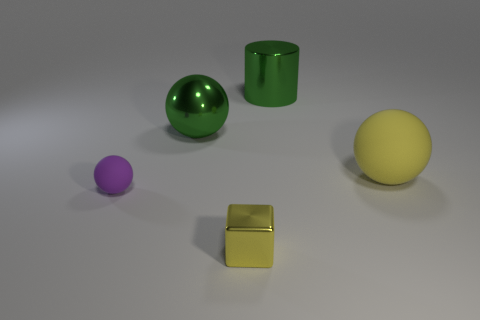What number of other yellow metallic things are the same size as the yellow metallic thing?
Ensure brevity in your answer.  0. There is a yellow thing that is in front of the purple sphere; what number of tiny spheres are in front of it?
Ensure brevity in your answer.  0. There is a sphere that is on the left side of the large cylinder and right of the tiny purple thing; what is its size?
Keep it short and to the point. Large. Are there more purple rubber things than large gray matte cubes?
Offer a very short reply. Yes. Are there any large objects of the same color as the cylinder?
Ensure brevity in your answer.  Yes. Is the size of the green thing to the left of the green metallic cylinder the same as the big matte thing?
Provide a short and direct response. Yes. Is the number of large rubber balls less than the number of tiny gray rubber things?
Offer a very short reply. No. Is there a yellow thing that has the same material as the tiny purple ball?
Your answer should be very brief. Yes. What shape is the matte thing that is right of the small purple sphere?
Make the answer very short. Sphere. Is the color of the rubber ball to the right of the green shiny cylinder the same as the tiny metal thing?
Ensure brevity in your answer.  Yes. 